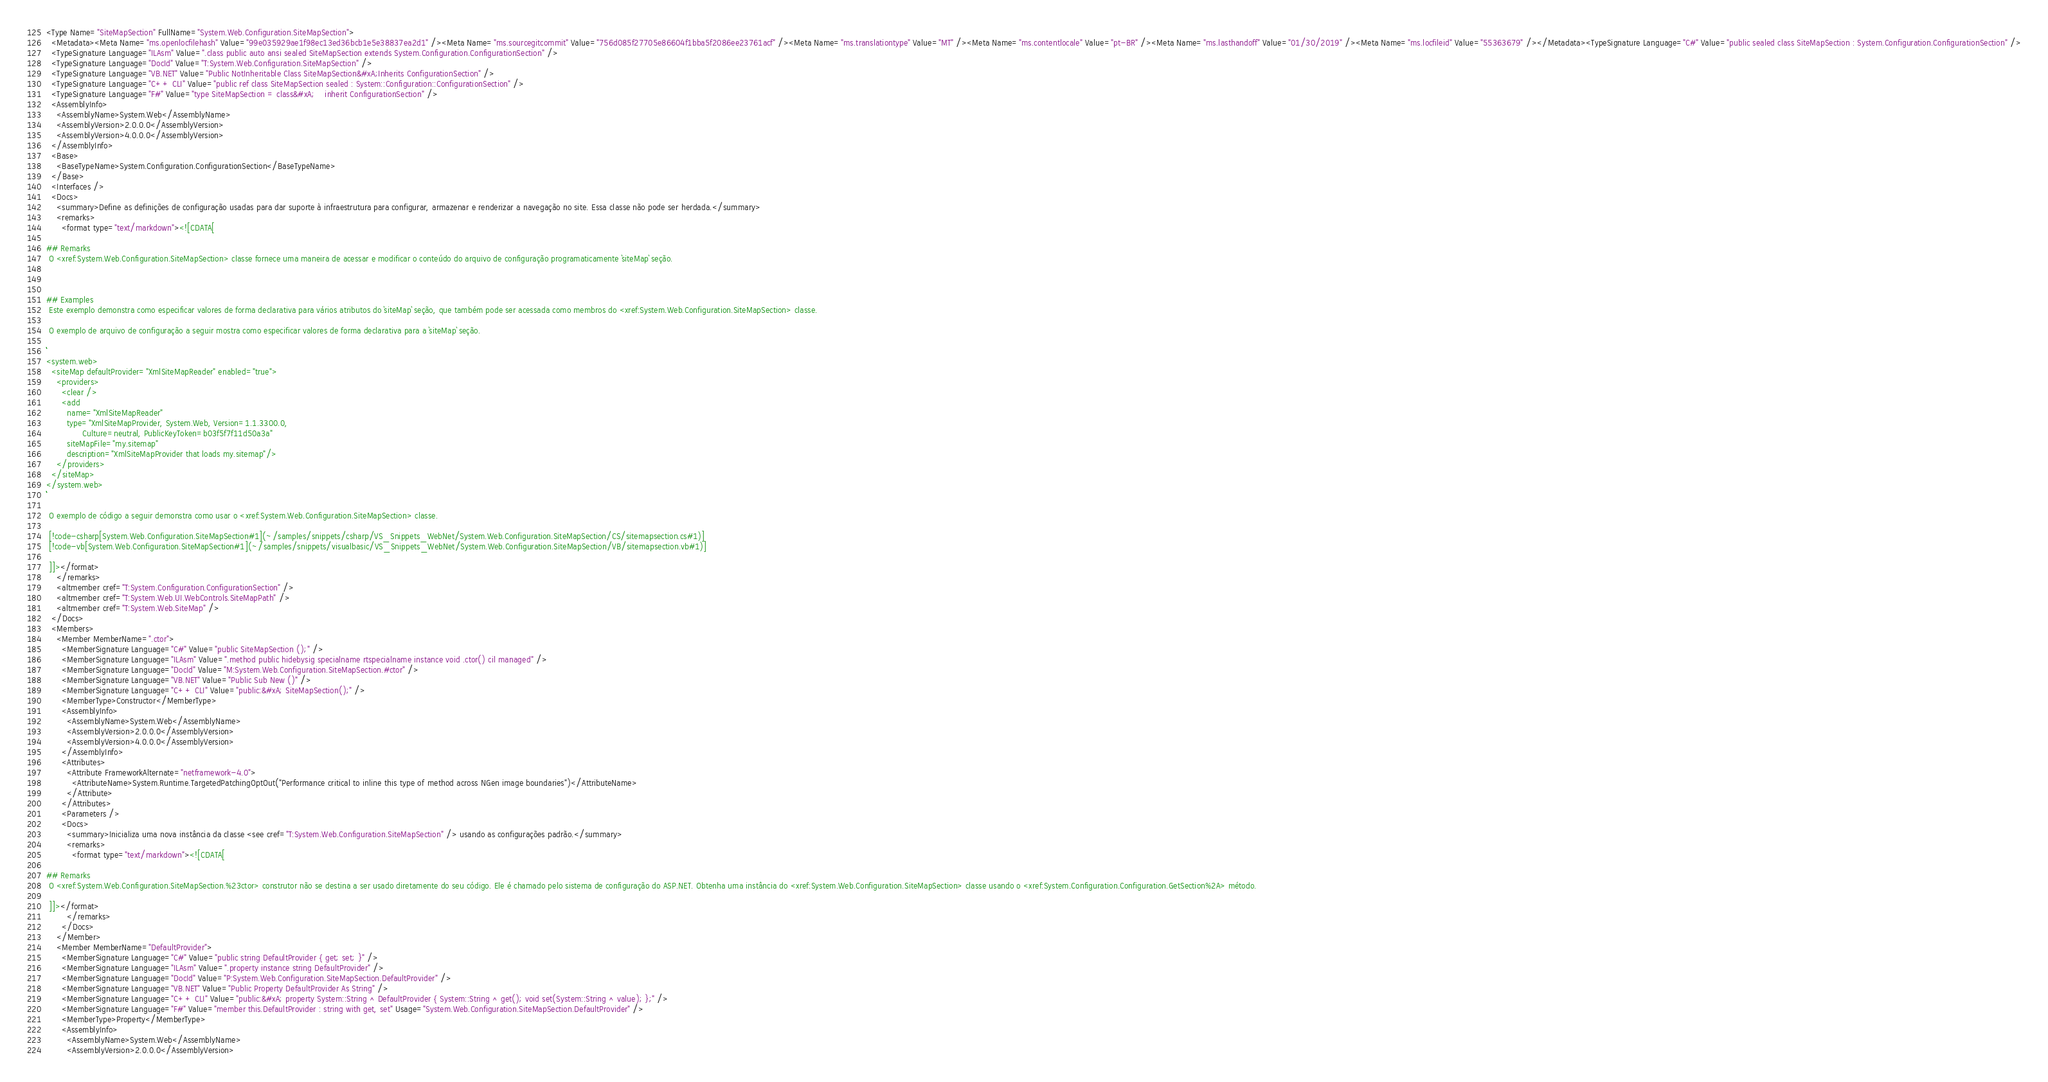Convert code to text. <code><loc_0><loc_0><loc_500><loc_500><_XML_><Type Name="SiteMapSection" FullName="System.Web.Configuration.SiteMapSection">
  <Metadata><Meta Name="ms.openlocfilehash" Value="99e035929ae1f98ec13ed36bcb1e5e38837ea2d1" /><Meta Name="ms.sourcegitcommit" Value="756d085f27705e86604f1bba5f2086ee23761acf" /><Meta Name="ms.translationtype" Value="MT" /><Meta Name="ms.contentlocale" Value="pt-BR" /><Meta Name="ms.lasthandoff" Value="01/30/2019" /><Meta Name="ms.locfileid" Value="55363679" /></Metadata><TypeSignature Language="C#" Value="public sealed class SiteMapSection : System.Configuration.ConfigurationSection" />
  <TypeSignature Language="ILAsm" Value=".class public auto ansi sealed SiteMapSection extends System.Configuration.ConfigurationSection" />
  <TypeSignature Language="DocId" Value="T:System.Web.Configuration.SiteMapSection" />
  <TypeSignature Language="VB.NET" Value="Public NotInheritable Class SiteMapSection&#xA;Inherits ConfigurationSection" />
  <TypeSignature Language="C++ CLI" Value="public ref class SiteMapSection sealed : System::Configuration::ConfigurationSection" />
  <TypeSignature Language="F#" Value="type SiteMapSection = class&#xA;    inherit ConfigurationSection" />
  <AssemblyInfo>
    <AssemblyName>System.Web</AssemblyName>
    <AssemblyVersion>2.0.0.0</AssemblyVersion>
    <AssemblyVersion>4.0.0.0</AssemblyVersion>
  </AssemblyInfo>
  <Base>
    <BaseTypeName>System.Configuration.ConfigurationSection</BaseTypeName>
  </Base>
  <Interfaces />
  <Docs>
    <summary>Define as definições de configuração usadas para dar suporte à infraestrutura para configurar, armazenar e renderizar a navegação no site. Essa classe não pode ser herdada.</summary>
    <remarks>
      <format type="text/markdown"><![CDATA[  
  
## Remarks  
 O <xref:System.Web.Configuration.SiteMapSection> classe fornece uma maneira de acessar e modificar o conteúdo do arquivo de configuração programaticamente `siteMap` seção.  
  
   
  
## Examples  
 Este exemplo demonstra como especificar valores de forma declarativa para vários atributos do `siteMap` seção, que também pode ser acessada como membros do <xref:System.Web.Configuration.SiteMapSection> classe.  
  
 O exemplo de arquivo de configuração a seguir mostra como especificar valores de forma declarativa para a `siteMap` seção.  
  
```  
<system.web>  
  <siteMap defaultProvider="XmlSiteMapReader" enabled="true">  
    <providers>  
      <clear />  
      <add   
        name="XmlSiteMapReader"  
        type="XmlSiteMapProvider, System.Web, Version=1.1.3300.0,  
              Culture=neutral, PublicKeyToken=b03f5f7f11d50a3a"  
        siteMapFile="my.sitemap"   
        description="XmlSiteMapProvider that loads my.sitemap"/>  
    </providers>  
  </siteMap>  
</system.web>  
```  
  
 O exemplo de código a seguir demonstra como usar o <xref:System.Web.Configuration.SiteMapSection> classe.  
  
 [!code-csharp[System.Web.Configuration.SiteMapSection#1](~/samples/snippets/csharp/VS_Snippets_WebNet/System.Web.Configuration.SiteMapSection/CS/sitemapsection.cs#1)]
 [!code-vb[System.Web.Configuration.SiteMapSection#1](~/samples/snippets/visualbasic/VS_Snippets_WebNet/System.Web.Configuration.SiteMapSection/VB/sitemapsection.vb#1)]  
  
 ]]></format>
    </remarks>
    <altmember cref="T:System.Configuration.ConfigurationSection" />
    <altmember cref="T:System.Web.UI.WebControls.SiteMapPath" />
    <altmember cref="T:System.Web.SiteMap" />
  </Docs>
  <Members>
    <Member MemberName=".ctor">
      <MemberSignature Language="C#" Value="public SiteMapSection ();" />
      <MemberSignature Language="ILAsm" Value=".method public hidebysig specialname rtspecialname instance void .ctor() cil managed" />
      <MemberSignature Language="DocId" Value="M:System.Web.Configuration.SiteMapSection.#ctor" />
      <MemberSignature Language="VB.NET" Value="Public Sub New ()" />
      <MemberSignature Language="C++ CLI" Value="public:&#xA; SiteMapSection();" />
      <MemberType>Constructor</MemberType>
      <AssemblyInfo>
        <AssemblyName>System.Web</AssemblyName>
        <AssemblyVersion>2.0.0.0</AssemblyVersion>
        <AssemblyVersion>4.0.0.0</AssemblyVersion>
      </AssemblyInfo>
      <Attributes>
        <Attribute FrameworkAlternate="netframework-4.0">
          <AttributeName>System.Runtime.TargetedPatchingOptOut("Performance critical to inline this type of method across NGen image boundaries")</AttributeName>
        </Attribute>
      </Attributes>
      <Parameters />
      <Docs>
        <summary>Inicializa uma nova instância da classe <see cref="T:System.Web.Configuration.SiteMapSection" /> usando as configurações padrão.</summary>
        <remarks>
          <format type="text/markdown"><![CDATA[  
  
## Remarks  
 O <xref:System.Web.Configuration.SiteMapSection.%23ctor> construtor não se destina a ser usado diretamente do seu código. Ele é chamado pelo sistema de configuração do ASP.NET. Obtenha uma instância do <xref:System.Web.Configuration.SiteMapSection> classe usando o <xref:System.Configuration.Configuration.GetSection%2A> método.  
  
 ]]></format>
        </remarks>
      </Docs>
    </Member>
    <Member MemberName="DefaultProvider">
      <MemberSignature Language="C#" Value="public string DefaultProvider { get; set; }" />
      <MemberSignature Language="ILAsm" Value=".property instance string DefaultProvider" />
      <MemberSignature Language="DocId" Value="P:System.Web.Configuration.SiteMapSection.DefaultProvider" />
      <MemberSignature Language="VB.NET" Value="Public Property DefaultProvider As String" />
      <MemberSignature Language="C++ CLI" Value="public:&#xA; property System::String ^ DefaultProvider { System::String ^ get(); void set(System::String ^ value); };" />
      <MemberSignature Language="F#" Value="member this.DefaultProvider : string with get, set" Usage="System.Web.Configuration.SiteMapSection.DefaultProvider" />
      <MemberType>Property</MemberType>
      <AssemblyInfo>
        <AssemblyName>System.Web</AssemblyName>
        <AssemblyVersion>2.0.0.0</AssemblyVersion></code> 